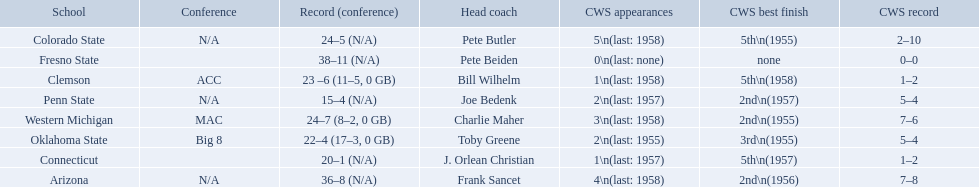What were scores for each school in the 1959 ncaa tournament? 36–8 (N/A), 23 –6 (11–5, 0 GB), 24–5 (N/A), 20–1 (N/A), 38–11 (N/A), 22–4 (17–3, 0 GB), 15–4 (N/A), 24–7 (8–2, 0 GB). What score did not have at least 16 wins? 15–4 (N/A). What team earned this score? Penn State. 